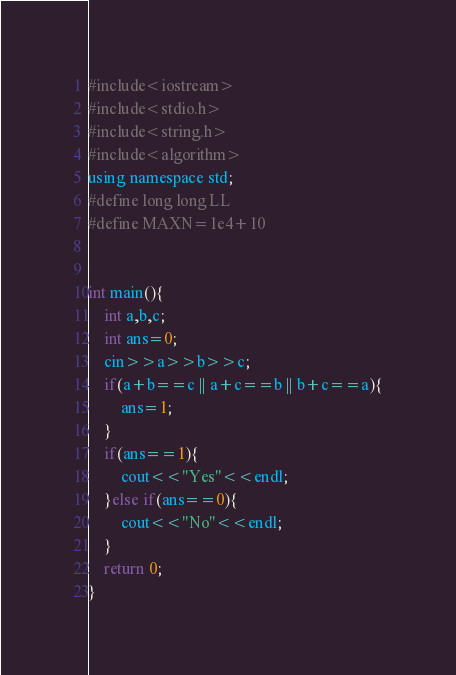Convert code to text. <code><loc_0><loc_0><loc_500><loc_500><_Awk_>#include<iostream>
#include<stdio.h>
#include<string.h>
#include<algorithm>
using namespace std;
#define long long LL     
#define MAXN=1e4+10    


int main(){
	int a,b,c;
	int ans=0;
	cin>>a>>b>>c;
	if(a+b==c || a+c==b || b+c==a){
		ans=1;
	}
	if(ans==1){
		cout<<"Yes"<<endl;
	}else if(ans==0){
		cout<<"No"<<endl;
	}
	return 0;
}</code> 